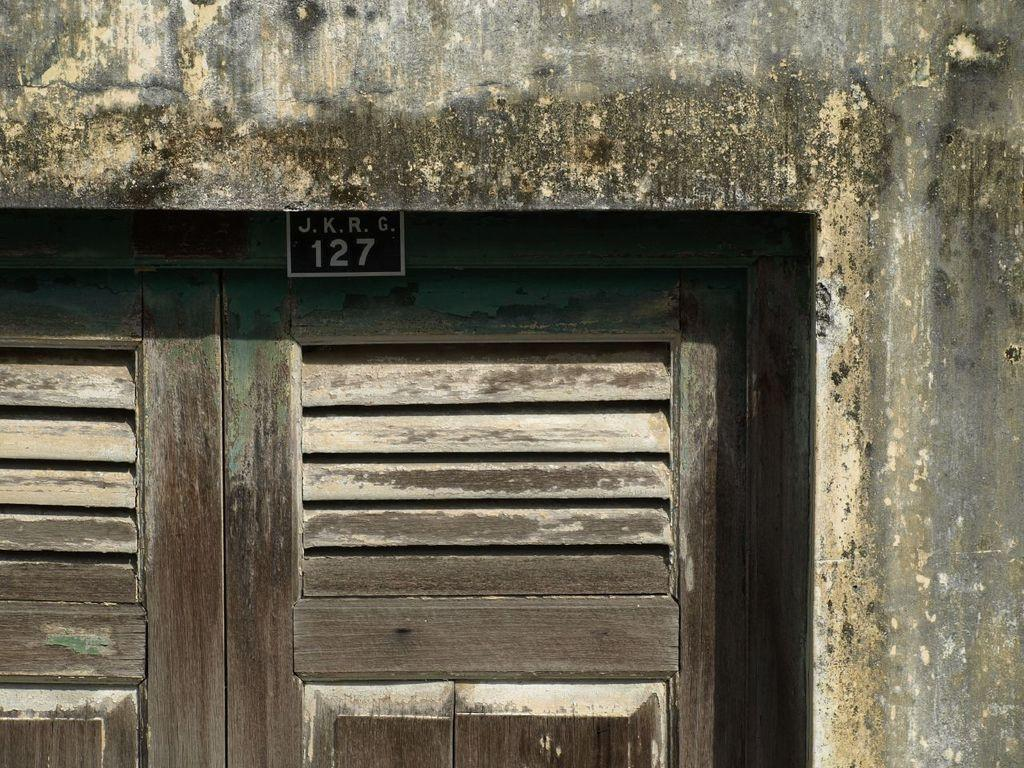How many doors can be seen in the image? There are two doors in the image. Where are the doors located? The doors are along a wall. What is attached to the top of the doors? There is a black color paper attached to the top of the doors. What is written on the paper? The paper has text and numbers on it. What type of wax is used to seal the statement on the paper in the image? There is no statement or wax present in the image; it only features two doors with a black color paper attached to the top, which has text and numbers on it. 